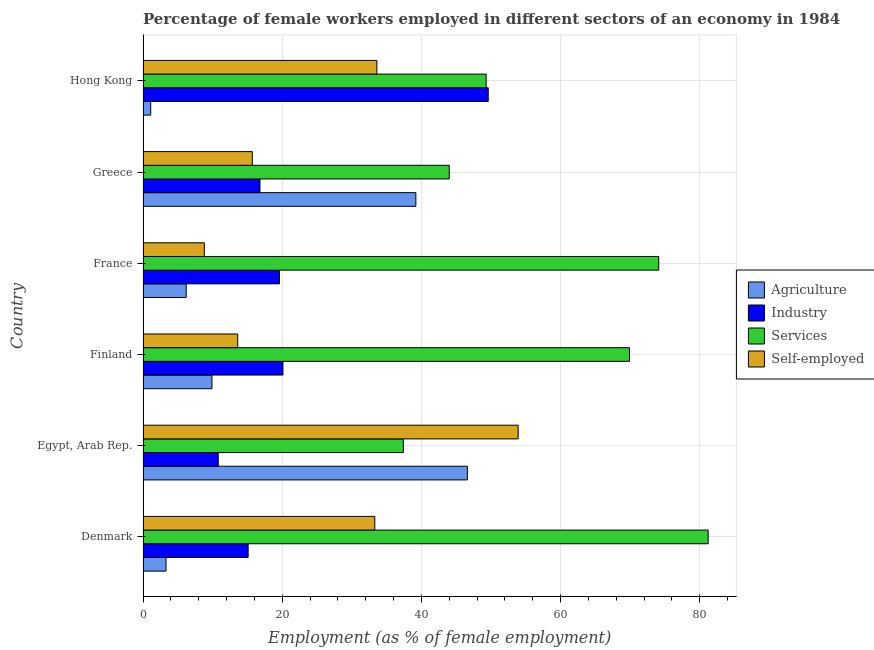In how many cases, is the number of bars for a given country not equal to the number of legend labels?
Keep it short and to the point. 0. What is the percentage of self employed female workers in France?
Provide a succinct answer. 8.8. Across all countries, what is the maximum percentage of female workers in agriculture?
Keep it short and to the point. 46.6. Across all countries, what is the minimum percentage of self employed female workers?
Your response must be concise. 8.8. In which country was the percentage of female workers in agriculture maximum?
Ensure brevity in your answer.  Egypt, Arab Rep. What is the total percentage of female workers in industry in the graph?
Ensure brevity in your answer.  132. What is the difference between the percentage of self employed female workers in Finland and the percentage of female workers in agriculture in Hong Kong?
Provide a short and direct response. 12.5. What is the average percentage of female workers in services per country?
Offer a very short reply. 59.32. What is the difference between the percentage of female workers in agriculture and percentage of female workers in services in Denmark?
Ensure brevity in your answer.  -77.9. In how many countries, is the percentage of female workers in industry greater than 72 %?
Offer a very short reply. 0. What is the ratio of the percentage of female workers in industry in France to that in Greece?
Provide a succinct answer. 1.17. Is the percentage of female workers in agriculture in Egypt, Arab Rep. less than that in Greece?
Provide a succinct answer. No. Is the difference between the percentage of self employed female workers in Finland and France greater than the difference between the percentage of female workers in agriculture in Finland and France?
Provide a succinct answer. Yes. What is the difference between the highest and the second highest percentage of self employed female workers?
Make the answer very short. 20.3. What is the difference between the highest and the lowest percentage of female workers in agriculture?
Provide a short and direct response. 45.5. In how many countries, is the percentage of female workers in industry greater than the average percentage of female workers in industry taken over all countries?
Your answer should be compact. 1. Is the sum of the percentage of female workers in services in Denmark and Hong Kong greater than the maximum percentage of female workers in industry across all countries?
Offer a very short reply. Yes. Is it the case that in every country, the sum of the percentage of self employed female workers and percentage of female workers in services is greater than the sum of percentage of female workers in industry and percentage of female workers in agriculture?
Your response must be concise. Yes. What does the 3rd bar from the top in Egypt, Arab Rep. represents?
Your answer should be compact. Industry. What does the 3rd bar from the bottom in Egypt, Arab Rep. represents?
Provide a succinct answer. Services. Is it the case that in every country, the sum of the percentage of female workers in agriculture and percentage of female workers in industry is greater than the percentage of female workers in services?
Offer a very short reply. No. Are all the bars in the graph horizontal?
Provide a succinct answer. Yes. Does the graph contain grids?
Your answer should be compact. Yes. How are the legend labels stacked?
Provide a succinct answer. Vertical. What is the title of the graph?
Make the answer very short. Percentage of female workers employed in different sectors of an economy in 1984. Does "Korea" appear as one of the legend labels in the graph?
Keep it short and to the point. No. What is the label or title of the X-axis?
Provide a short and direct response. Employment (as % of female employment). What is the Employment (as % of female employment) in Agriculture in Denmark?
Your response must be concise. 3.3. What is the Employment (as % of female employment) in Industry in Denmark?
Your answer should be very brief. 15.1. What is the Employment (as % of female employment) in Services in Denmark?
Your response must be concise. 81.2. What is the Employment (as % of female employment) of Self-employed in Denmark?
Give a very brief answer. 33.3. What is the Employment (as % of female employment) of Agriculture in Egypt, Arab Rep.?
Keep it short and to the point. 46.6. What is the Employment (as % of female employment) of Industry in Egypt, Arab Rep.?
Provide a succinct answer. 10.8. What is the Employment (as % of female employment) in Services in Egypt, Arab Rep.?
Make the answer very short. 37.4. What is the Employment (as % of female employment) of Self-employed in Egypt, Arab Rep.?
Make the answer very short. 53.9. What is the Employment (as % of female employment) in Agriculture in Finland?
Ensure brevity in your answer.  9.9. What is the Employment (as % of female employment) in Industry in Finland?
Your answer should be very brief. 20.1. What is the Employment (as % of female employment) in Services in Finland?
Your answer should be compact. 69.9. What is the Employment (as % of female employment) in Self-employed in Finland?
Ensure brevity in your answer.  13.6. What is the Employment (as % of female employment) of Agriculture in France?
Give a very brief answer. 6.2. What is the Employment (as % of female employment) of Industry in France?
Give a very brief answer. 19.6. What is the Employment (as % of female employment) of Services in France?
Your answer should be compact. 74.1. What is the Employment (as % of female employment) of Self-employed in France?
Ensure brevity in your answer.  8.8. What is the Employment (as % of female employment) in Agriculture in Greece?
Make the answer very short. 39.2. What is the Employment (as % of female employment) in Industry in Greece?
Give a very brief answer. 16.8. What is the Employment (as % of female employment) of Self-employed in Greece?
Keep it short and to the point. 15.7. What is the Employment (as % of female employment) of Agriculture in Hong Kong?
Keep it short and to the point. 1.1. What is the Employment (as % of female employment) in Industry in Hong Kong?
Give a very brief answer. 49.6. What is the Employment (as % of female employment) in Services in Hong Kong?
Your answer should be very brief. 49.3. What is the Employment (as % of female employment) in Self-employed in Hong Kong?
Offer a terse response. 33.6. Across all countries, what is the maximum Employment (as % of female employment) of Agriculture?
Give a very brief answer. 46.6. Across all countries, what is the maximum Employment (as % of female employment) in Industry?
Provide a short and direct response. 49.6. Across all countries, what is the maximum Employment (as % of female employment) of Services?
Your answer should be compact. 81.2. Across all countries, what is the maximum Employment (as % of female employment) in Self-employed?
Provide a succinct answer. 53.9. Across all countries, what is the minimum Employment (as % of female employment) in Agriculture?
Keep it short and to the point. 1.1. Across all countries, what is the minimum Employment (as % of female employment) of Industry?
Provide a short and direct response. 10.8. Across all countries, what is the minimum Employment (as % of female employment) in Services?
Offer a very short reply. 37.4. Across all countries, what is the minimum Employment (as % of female employment) in Self-employed?
Make the answer very short. 8.8. What is the total Employment (as % of female employment) of Agriculture in the graph?
Offer a terse response. 106.3. What is the total Employment (as % of female employment) in Industry in the graph?
Offer a very short reply. 132. What is the total Employment (as % of female employment) in Services in the graph?
Offer a terse response. 355.9. What is the total Employment (as % of female employment) of Self-employed in the graph?
Your response must be concise. 158.9. What is the difference between the Employment (as % of female employment) in Agriculture in Denmark and that in Egypt, Arab Rep.?
Make the answer very short. -43.3. What is the difference between the Employment (as % of female employment) of Services in Denmark and that in Egypt, Arab Rep.?
Offer a terse response. 43.8. What is the difference between the Employment (as % of female employment) in Self-employed in Denmark and that in Egypt, Arab Rep.?
Offer a very short reply. -20.6. What is the difference between the Employment (as % of female employment) of Agriculture in Denmark and that in Finland?
Your answer should be very brief. -6.6. What is the difference between the Employment (as % of female employment) in Services in Denmark and that in Finland?
Provide a short and direct response. 11.3. What is the difference between the Employment (as % of female employment) in Self-employed in Denmark and that in Finland?
Provide a succinct answer. 19.7. What is the difference between the Employment (as % of female employment) of Industry in Denmark and that in France?
Keep it short and to the point. -4.5. What is the difference between the Employment (as % of female employment) of Agriculture in Denmark and that in Greece?
Your answer should be compact. -35.9. What is the difference between the Employment (as % of female employment) of Industry in Denmark and that in Greece?
Keep it short and to the point. -1.7. What is the difference between the Employment (as % of female employment) in Services in Denmark and that in Greece?
Provide a short and direct response. 37.2. What is the difference between the Employment (as % of female employment) in Self-employed in Denmark and that in Greece?
Keep it short and to the point. 17.6. What is the difference between the Employment (as % of female employment) in Industry in Denmark and that in Hong Kong?
Your answer should be compact. -34.5. What is the difference between the Employment (as % of female employment) of Services in Denmark and that in Hong Kong?
Offer a very short reply. 31.9. What is the difference between the Employment (as % of female employment) in Self-employed in Denmark and that in Hong Kong?
Offer a terse response. -0.3. What is the difference between the Employment (as % of female employment) in Agriculture in Egypt, Arab Rep. and that in Finland?
Offer a very short reply. 36.7. What is the difference between the Employment (as % of female employment) of Industry in Egypt, Arab Rep. and that in Finland?
Your response must be concise. -9.3. What is the difference between the Employment (as % of female employment) in Services in Egypt, Arab Rep. and that in Finland?
Provide a succinct answer. -32.5. What is the difference between the Employment (as % of female employment) in Self-employed in Egypt, Arab Rep. and that in Finland?
Offer a very short reply. 40.3. What is the difference between the Employment (as % of female employment) of Agriculture in Egypt, Arab Rep. and that in France?
Offer a terse response. 40.4. What is the difference between the Employment (as % of female employment) in Industry in Egypt, Arab Rep. and that in France?
Ensure brevity in your answer.  -8.8. What is the difference between the Employment (as % of female employment) of Services in Egypt, Arab Rep. and that in France?
Keep it short and to the point. -36.7. What is the difference between the Employment (as % of female employment) of Self-employed in Egypt, Arab Rep. and that in France?
Make the answer very short. 45.1. What is the difference between the Employment (as % of female employment) in Agriculture in Egypt, Arab Rep. and that in Greece?
Offer a terse response. 7.4. What is the difference between the Employment (as % of female employment) in Self-employed in Egypt, Arab Rep. and that in Greece?
Provide a short and direct response. 38.2. What is the difference between the Employment (as % of female employment) of Agriculture in Egypt, Arab Rep. and that in Hong Kong?
Keep it short and to the point. 45.5. What is the difference between the Employment (as % of female employment) in Industry in Egypt, Arab Rep. and that in Hong Kong?
Provide a short and direct response. -38.8. What is the difference between the Employment (as % of female employment) of Self-employed in Egypt, Arab Rep. and that in Hong Kong?
Your response must be concise. 20.3. What is the difference between the Employment (as % of female employment) of Agriculture in Finland and that in France?
Provide a succinct answer. 3.7. What is the difference between the Employment (as % of female employment) of Agriculture in Finland and that in Greece?
Ensure brevity in your answer.  -29.3. What is the difference between the Employment (as % of female employment) in Services in Finland and that in Greece?
Your answer should be compact. 25.9. What is the difference between the Employment (as % of female employment) in Self-employed in Finland and that in Greece?
Ensure brevity in your answer.  -2.1. What is the difference between the Employment (as % of female employment) of Industry in Finland and that in Hong Kong?
Provide a short and direct response. -29.5. What is the difference between the Employment (as % of female employment) of Services in Finland and that in Hong Kong?
Make the answer very short. 20.6. What is the difference between the Employment (as % of female employment) in Self-employed in Finland and that in Hong Kong?
Your response must be concise. -20. What is the difference between the Employment (as % of female employment) in Agriculture in France and that in Greece?
Offer a very short reply. -33. What is the difference between the Employment (as % of female employment) in Industry in France and that in Greece?
Keep it short and to the point. 2.8. What is the difference between the Employment (as % of female employment) in Services in France and that in Greece?
Keep it short and to the point. 30.1. What is the difference between the Employment (as % of female employment) in Industry in France and that in Hong Kong?
Offer a terse response. -30. What is the difference between the Employment (as % of female employment) of Services in France and that in Hong Kong?
Provide a short and direct response. 24.8. What is the difference between the Employment (as % of female employment) of Self-employed in France and that in Hong Kong?
Your answer should be compact. -24.8. What is the difference between the Employment (as % of female employment) of Agriculture in Greece and that in Hong Kong?
Provide a short and direct response. 38.1. What is the difference between the Employment (as % of female employment) in Industry in Greece and that in Hong Kong?
Your answer should be very brief. -32.8. What is the difference between the Employment (as % of female employment) of Self-employed in Greece and that in Hong Kong?
Offer a terse response. -17.9. What is the difference between the Employment (as % of female employment) of Agriculture in Denmark and the Employment (as % of female employment) of Services in Egypt, Arab Rep.?
Offer a terse response. -34.1. What is the difference between the Employment (as % of female employment) in Agriculture in Denmark and the Employment (as % of female employment) in Self-employed in Egypt, Arab Rep.?
Offer a terse response. -50.6. What is the difference between the Employment (as % of female employment) in Industry in Denmark and the Employment (as % of female employment) in Services in Egypt, Arab Rep.?
Ensure brevity in your answer.  -22.3. What is the difference between the Employment (as % of female employment) of Industry in Denmark and the Employment (as % of female employment) of Self-employed in Egypt, Arab Rep.?
Your answer should be very brief. -38.8. What is the difference between the Employment (as % of female employment) of Services in Denmark and the Employment (as % of female employment) of Self-employed in Egypt, Arab Rep.?
Your answer should be compact. 27.3. What is the difference between the Employment (as % of female employment) in Agriculture in Denmark and the Employment (as % of female employment) in Industry in Finland?
Provide a succinct answer. -16.8. What is the difference between the Employment (as % of female employment) in Agriculture in Denmark and the Employment (as % of female employment) in Services in Finland?
Give a very brief answer. -66.6. What is the difference between the Employment (as % of female employment) in Industry in Denmark and the Employment (as % of female employment) in Services in Finland?
Your answer should be very brief. -54.8. What is the difference between the Employment (as % of female employment) of Industry in Denmark and the Employment (as % of female employment) of Self-employed in Finland?
Provide a succinct answer. 1.5. What is the difference between the Employment (as % of female employment) in Services in Denmark and the Employment (as % of female employment) in Self-employed in Finland?
Your response must be concise. 67.6. What is the difference between the Employment (as % of female employment) of Agriculture in Denmark and the Employment (as % of female employment) of Industry in France?
Provide a succinct answer. -16.3. What is the difference between the Employment (as % of female employment) in Agriculture in Denmark and the Employment (as % of female employment) in Services in France?
Keep it short and to the point. -70.8. What is the difference between the Employment (as % of female employment) of Agriculture in Denmark and the Employment (as % of female employment) of Self-employed in France?
Provide a succinct answer. -5.5. What is the difference between the Employment (as % of female employment) of Industry in Denmark and the Employment (as % of female employment) of Services in France?
Give a very brief answer. -59. What is the difference between the Employment (as % of female employment) in Services in Denmark and the Employment (as % of female employment) in Self-employed in France?
Give a very brief answer. 72.4. What is the difference between the Employment (as % of female employment) of Agriculture in Denmark and the Employment (as % of female employment) of Services in Greece?
Your answer should be very brief. -40.7. What is the difference between the Employment (as % of female employment) in Agriculture in Denmark and the Employment (as % of female employment) in Self-employed in Greece?
Your response must be concise. -12.4. What is the difference between the Employment (as % of female employment) of Industry in Denmark and the Employment (as % of female employment) of Services in Greece?
Keep it short and to the point. -28.9. What is the difference between the Employment (as % of female employment) of Services in Denmark and the Employment (as % of female employment) of Self-employed in Greece?
Your answer should be very brief. 65.5. What is the difference between the Employment (as % of female employment) of Agriculture in Denmark and the Employment (as % of female employment) of Industry in Hong Kong?
Your answer should be very brief. -46.3. What is the difference between the Employment (as % of female employment) of Agriculture in Denmark and the Employment (as % of female employment) of Services in Hong Kong?
Offer a terse response. -46. What is the difference between the Employment (as % of female employment) in Agriculture in Denmark and the Employment (as % of female employment) in Self-employed in Hong Kong?
Your response must be concise. -30.3. What is the difference between the Employment (as % of female employment) of Industry in Denmark and the Employment (as % of female employment) of Services in Hong Kong?
Ensure brevity in your answer.  -34.2. What is the difference between the Employment (as % of female employment) in Industry in Denmark and the Employment (as % of female employment) in Self-employed in Hong Kong?
Provide a succinct answer. -18.5. What is the difference between the Employment (as % of female employment) in Services in Denmark and the Employment (as % of female employment) in Self-employed in Hong Kong?
Give a very brief answer. 47.6. What is the difference between the Employment (as % of female employment) in Agriculture in Egypt, Arab Rep. and the Employment (as % of female employment) in Industry in Finland?
Give a very brief answer. 26.5. What is the difference between the Employment (as % of female employment) of Agriculture in Egypt, Arab Rep. and the Employment (as % of female employment) of Services in Finland?
Make the answer very short. -23.3. What is the difference between the Employment (as % of female employment) in Industry in Egypt, Arab Rep. and the Employment (as % of female employment) in Services in Finland?
Keep it short and to the point. -59.1. What is the difference between the Employment (as % of female employment) in Services in Egypt, Arab Rep. and the Employment (as % of female employment) in Self-employed in Finland?
Ensure brevity in your answer.  23.8. What is the difference between the Employment (as % of female employment) of Agriculture in Egypt, Arab Rep. and the Employment (as % of female employment) of Industry in France?
Offer a terse response. 27. What is the difference between the Employment (as % of female employment) in Agriculture in Egypt, Arab Rep. and the Employment (as % of female employment) in Services in France?
Your answer should be very brief. -27.5. What is the difference between the Employment (as % of female employment) in Agriculture in Egypt, Arab Rep. and the Employment (as % of female employment) in Self-employed in France?
Ensure brevity in your answer.  37.8. What is the difference between the Employment (as % of female employment) in Industry in Egypt, Arab Rep. and the Employment (as % of female employment) in Services in France?
Your answer should be compact. -63.3. What is the difference between the Employment (as % of female employment) in Services in Egypt, Arab Rep. and the Employment (as % of female employment) in Self-employed in France?
Your response must be concise. 28.6. What is the difference between the Employment (as % of female employment) of Agriculture in Egypt, Arab Rep. and the Employment (as % of female employment) of Industry in Greece?
Ensure brevity in your answer.  29.8. What is the difference between the Employment (as % of female employment) in Agriculture in Egypt, Arab Rep. and the Employment (as % of female employment) in Self-employed in Greece?
Your answer should be compact. 30.9. What is the difference between the Employment (as % of female employment) in Industry in Egypt, Arab Rep. and the Employment (as % of female employment) in Services in Greece?
Provide a succinct answer. -33.2. What is the difference between the Employment (as % of female employment) in Industry in Egypt, Arab Rep. and the Employment (as % of female employment) in Self-employed in Greece?
Keep it short and to the point. -4.9. What is the difference between the Employment (as % of female employment) in Services in Egypt, Arab Rep. and the Employment (as % of female employment) in Self-employed in Greece?
Offer a very short reply. 21.7. What is the difference between the Employment (as % of female employment) of Agriculture in Egypt, Arab Rep. and the Employment (as % of female employment) of Industry in Hong Kong?
Offer a terse response. -3. What is the difference between the Employment (as % of female employment) of Agriculture in Egypt, Arab Rep. and the Employment (as % of female employment) of Self-employed in Hong Kong?
Provide a succinct answer. 13. What is the difference between the Employment (as % of female employment) in Industry in Egypt, Arab Rep. and the Employment (as % of female employment) in Services in Hong Kong?
Provide a short and direct response. -38.5. What is the difference between the Employment (as % of female employment) in Industry in Egypt, Arab Rep. and the Employment (as % of female employment) in Self-employed in Hong Kong?
Ensure brevity in your answer.  -22.8. What is the difference between the Employment (as % of female employment) of Agriculture in Finland and the Employment (as % of female employment) of Industry in France?
Provide a short and direct response. -9.7. What is the difference between the Employment (as % of female employment) of Agriculture in Finland and the Employment (as % of female employment) of Services in France?
Give a very brief answer. -64.2. What is the difference between the Employment (as % of female employment) of Industry in Finland and the Employment (as % of female employment) of Services in France?
Make the answer very short. -54. What is the difference between the Employment (as % of female employment) in Services in Finland and the Employment (as % of female employment) in Self-employed in France?
Keep it short and to the point. 61.1. What is the difference between the Employment (as % of female employment) in Agriculture in Finland and the Employment (as % of female employment) in Services in Greece?
Provide a short and direct response. -34.1. What is the difference between the Employment (as % of female employment) in Industry in Finland and the Employment (as % of female employment) in Services in Greece?
Your answer should be compact. -23.9. What is the difference between the Employment (as % of female employment) in Services in Finland and the Employment (as % of female employment) in Self-employed in Greece?
Offer a very short reply. 54.2. What is the difference between the Employment (as % of female employment) in Agriculture in Finland and the Employment (as % of female employment) in Industry in Hong Kong?
Your answer should be compact. -39.7. What is the difference between the Employment (as % of female employment) in Agriculture in Finland and the Employment (as % of female employment) in Services in Hong Kong?
Offer a very short reply. -39.4. What is the difference between the Employment (as % of female employment) of Agriculture in Finland and the Employment (as % of female employment) of Self-employed in Hong Kong?
Ensure brevity in your answer.  -23.7. What is the difference between the Employment (as % of female employment) in Industry in Finland and the Employment (as % of female employment) in Services in Hong Kong?
Your answer should be compact. -29.2. What is the difference between the Employment (as % of female employment) in Services in Finland and the Employment (as % of female employment) in Self-employed in Hong Kong?
Ensure brevity in your answer.  36.3. What is the difference between the Employment (as % of female employment) of Agriculture in France and the Employment (as % of female employment) of Industry in Greece?
Make the answer very short. -10.6. What is the difference between the Employment (as % of female employment) in Agriculture in France and the Employment (as % of female employment) in Services in Greece?
Offer a very short reply. -37.8. What is the difference between the Employment (as % of female employment) of Industry in France and the Employment (as % of female employment) of Services in Greece?
Keep it short and to the point. -24.4. What is the difference between the Employment (as % of female employment) in Services in France and the Employment (as % of female employment) in Self-employed in Greece?
Ensure brevity in your answer.  58.4. What is the difference between the Employment (as % of female employment) of Agriculture in France and the Employment (as % of female employment) of Industry in Hong Kong?
Ensure brevity in your answer.  -43.4. What is the difference between the Employment (as % of female employment) in Agriculture in France and the Employment (as % of female employment) in Services in Hong Kong?
Keep it short and to the point. -43.1. What is the difference between the Employment (as % of female employment) in Agriculture in France and the Employment (as % of female employment) in Self-employed in Hong Kong?
Make the answer very short. -27.4. What is the difference between the Employment (as % of female employment) of Industry in France and the Employment (as % of female employment) of Services in Hong Kong?
Offer a terse response. -29.7. What is the difference between the Employment (as % of female employment) in Services in France and the Employment (as % of female employment) in Self-employed in Hong Kong?
Ensure brevity in your answer.  40.5. What is the difference between the Employment (as % of female employment) in Agriculture in Greece and the Employment (as % of female employment) in Self-employed in Hong Kong?
Make the answer very short. 5.6. What is the difference between the Employment (as % of female employment) in Industry in Greece and the Employment (as % of female employment) in Services in Hong Kong?
Provide a succinct answer. -32.5. What is the difference between the Employment (as % of female employment) in Industry in Greece and the Employment (as % of female employment) in Self-employed in Hong Kong?
Keep it short and to the point. -16.8. What is the average Employment (as % of female employment) in Agriculture per country?
Your answer should be compact. 17.72. What is the average Employment (as % of female employment) of Services per country?
Your response must be concise. 59.32. What is the average Employment (as % of female employment) of Self-employed per country?
Keep it short and to the point. 26.48. What is the difference between the Employment (as % of female employment) of Agriculture and Employment (as % of female employment) of Industry in Denmark?
Your answer should be very brief. -11.8. What is the difference between the Employment (as % of female employment) of Agriculture and Employment (as % of female employment) of Services in Denmark?
Offer a terse response. -77.9. What is the difference between the Employment (as % of female employment) in Agriculture and Employment (as % of female employment) in Self-employed in Denmark?
Offer a very short reply. -30. What is the difference between the Employment (as % of female employment) of Industry and Employment (as % of female employment) of Services in Denmark?
Your answer should be very brief. -66.1. What is the difference between the Employment (as % of female employment) in Industry and Employment (as % of female employment) in Self-employed in Denmark?
Your answer should be compact. -18.2. What is the difference between the Employment (as % of female employment) of Services and Employment (as % of female employment) of Self-employed in Denmark?
Ensure brevity in your answer.  47.9. What is the difference between the Employment (as % of female employment) of Agriculture and Employment (as % of female employment) of Industry in Egypt, Arab Rep.?
Keep it short and to the point. 35.8. What is the difference between the Employment (as % of female employment) in Industry and Employment (as % of female employment) in Services in Egypt, Arab Rep.?
Provide a succinct answer. -26.6. What is the difference between the Employment (as % of female employment) in Industry and Employment (as % of female employment) in Self-employed in Egypt, Arab Rep.?
Make the answer very short. -43.1. What is the difference between the Employment (as % of female employment) of Services and Employment (as % of female employment) of Self-employed in Egypt, Arab Rep.?
Provide a short and direct response. -16.5. What is the difference between the Employment (as % of female employment) in Agriculture and Employment (as % of female employment) in Services in Finland?
Your answer should be compact. -60. What is the difference between the Employment (as % of female employment) of Industry and Employment (as % of female employment) of Services in Finland?
Your answer should be very brief. -49.8. What is the difference between the Employment (as % of female employment) in Industry and Employment (as % of female employment) in Self-employed in Finland?
Make the answer very short. 6.5. What is the difference between the Employment (as % of female employment) in Services and Employment (as % of female employment) in Self-employed in Finland?
Your answer should be very brief. 56.3. What is the difference between the Employment (as % of female employment) in Agriculture and Employment (as % of female employment) in Industry in France?
Make the answer very short. -13.4. What is the difference between the Employment (as % of female employment) of Agriculture and Employment (as % of female employment) of Services in France?
Provide a short and direct response. -67.9. What is the difference between the Employment (as % of female employment) in Industry and Employment (as % of female employment) in Services in France?
Your answer should be very brief. -54.5. What is the difference between the Employment (as % of female employment) in Industry and Employment (as % of female employment) in Self-employed in France?
Make the answer very short. 10.8. What is the difference between the Employment (as % of female employment) of Services and Employment (as % of female employment) of Self-employed in France?
Provide a succinct answer. 65.3. What is the difference between the Employment (as % of female employment) of Agriculture and Employment (as % of female employment) of Industry in Greece?
Offer a very short reply. 22.4. What is the difference between the Employment (as % of female employment) of Agriculture and Employment (as % of female employment) of Services in Greece?
Ensure brevity in your answer.  -4.8. What is the difference between the Employment (as % of female employment) of Agriculture and Employment (as % of female employment) of Self-employed in Greece?
Ensure brevity in your answer.  23.5. What is the difference between the Employment (as % of female employment) in Industry and Employment (as % of female employment) in Services in Greece?
Ensure brevity in your answer.  -27.2. What is the difference between the Employment (as % of female employment) of Services and Employment (as % of female employment) of Self-employed in Greece?
Keep it short and to the point. 28.3. What is the difference between the Employment (as % of female employment) in Agriculture and Employment (as % of female employment) in Industry in Hong Kong?
Your answer should be very brief. -48.5. What is the difference between the Employment (as % of female employment) in Agriculture and Employment (as % of female employment) in Services in Hong Kong?
Your response must be concise. -48.2. What is the difference between the Employment (as % of female employment) of Agriculture and Employment (as % of female employment) of Self-employed in Hong Kong?
Keep it short and to the point. -32.5. What is the difference between the Employment (as % of female employment) of Industry and Employment (as % of female employment) of Services in Hong Kong?
Give a very brief answer. 0.3. What is the difference between the Employment (as % of female employment) of Services and Employment (as % of female employment) of Self-employed in Hong Kong?
Provide a succinct answer. 15.7. What is the ratio of the Employment (as % of female employment) of Agriculture in Denmark to that in Egypt, Arab Rep.?
Your answer should be very brief. 0.07. What is the ratio of the Employment (as % of female employment) in Industry in Denmark to that in Egypt, Arab Rep.?
Provide a succinct answer. 1.4. What is the ratio of the Employment (as % of female employment) in Services in Denmark to that in Egypt, Arab Rep.?
Your response must be concise. 2.17. What is the ratio of the Employment (as % of female employment) of Self-employed in Denmark to that in Egypt, Arab Rep.?
Give a very brief answer. 0.62. What is the ratio of the Employment (as % of female employment) in Industry in Denmark to that in Finland?
Offer a terse response. 0.75. What is the ratio of the Employment (as % of female employment) in Services in Denmark to that in Finland?
Provide a succinct answer. 1.16. What is the ratio of the Employment (as % of female employment) in Self-employed in Denmark to that in Finland?
Your answer should be very brief. 2.45. What is the ratio of the Employment (as % of female employment) of Agriculture in Denmark to that in France?
Ensure brevity in your answer.  0.53. What is the ratio of the Employment (as % of female employment) of Industry in Denmark to that in France?
Offer a very short reply. 0.77. What is the ratio of the Employment (as % of female employment) in Services in Denmark to that in France?
Your answer should be very brief. 1.1. What is the ratio of the Employment (as % of female employment) in Self-employed in Denmark to that in France?
Provide a succinct answer. 3.78. What is the ratio of the Employment (as % of female employment) in Agriculture in Denmark to that in Greece?
Offer a very short reply. 0.08. What is the ratio of the Employment (as % of female employment) in Industry in Denmark to that in Greece?
Your answer should be very brief. 0.9. What is the ratio of the Employment (as % of female employment) in Services in Denmark to that in Greece?
Ensure brevity in your answer.  1.85. What is the ratio of the Employment (as % of female employment) of Self-employed in Denmark to that in Greece?
Your response must be concise. 2.12. What is the ratio of the Employment (as % of female employment) in Agriculture in Denmark to that in Hong Kong?
Keep it short and to the point. 3. What is the ratio of the Employment (as % of female employment) in Industry in Denmark to that in Hong Kong?
Your response must be concise. 0.3. What is the ratio of the Employment (as % of female employment) in Services in Denmark to that in Hong Kong?
Your response must be concise. 1.65. What is the ratio of the Employment (as % of female employment) in Agriculture in Egypt, Arab Rep. to that in Finland?
Offer a terse response. 4.71. What is the ratio of the Employment (as % of female employment) of Industry in Egypt, Arab Rep. to that in Finland?
Provide a succinct answer. 0.54. What is the ratio of the Employment (as % of female employment) of Services in Egypt, Arab Rep. to that in Finland?
Offer a very short reply. 0.54. What is the ratio of the Employment (as % of female employment) of Self-employed in Egypt, Arab Rep. to that in Finland?
Ensure brevity in your answer.  3.96. What is the ratio of the Employment (as % of female employment) of Agriculture in Egypt, Arab Rep. to that in France?
Your response must be concise. 7.52. What is the ratio of the Employment (as % of female employment) in Industry in Egypt, Arab Rep. to that in France?
Offer a very short reply. 0.55. What is the ratio of the Employment (as % of female employment) in Services in Egypt, Arab Rep. to that in France?
Offer a terse response. 0.5. What is the ratio of the Employment (as % of female employment) of Self-employed in Egypt, Arab Rep. to that in France?
Your response must be concise. 6.12. What is the ratio of the Employment (as % of female employment) of Agriculture in Egypt, Arab Rep. to that in Greece?
Your response must be concise. 1.19. What is the ratio of the Employment (as % of female employment) in Industry in Egypt, Arab Rep. to that in Greece?
Provide a short and direct response. 0.64. What is the ratio of the Employment (as % of female employment) of Self-employed in Egypt, Arab Rep. to that in Greece?
Your answer should be compact. 3.43. What is the ratio of the Employment (as % of female employment) in Agriculture in Egypt, Arab Rep. to that in Hong Kong?
Keep it short and to the point. 42.36. What is the ratio of the Employment (as % of female employment) in Industry in Egypt, Arab Rep. to that in Hong Kong?
Offer a very short reply. 0.22. What is the ratio of the Employment (as % of female employment) of Services in Egypt, Arab Rep. to that in Hong Kong?
Provide a short and direct response. 0.76. What is the ratio of the Employment (as % of female employment) in Self-employed in Egypt, Arab Rep. to that in Hong Kong?
Make the answer very short. 1.6. What is the ratio of the Employment (as % of female employment) in Agriculture in Finland to that in France?
Your answer should be compact. 1.6. What is the ratio of the Employment (as % of female employment) in Industry in Finland to that in France?
Give a very brief answer. 1.03. What is the ratio of the Employment (as % of female employment) of Services in Finland to that in France?
Provide a short and direct response. 0.94. What is the ratio of the Employment (as % of female employment) in Self-employed in Finland to that in France?
Make the answer very short. 1.55. What is the ratio of the Employment (as % of female employment) of Agriculture in Finland to that in Greece?
Provide a short and direct response. 0.25. What is the ratio of the Employment (as % of female employment) of Industry in Finland to that in Greece?
Keep it short and to the point. 1.2. What is the ratio of the Employment (as % of female employment) in Services in Finland to that in Greece?
Offer a terse response. 1.59. What is the ratio of the Employment (as % of female employment) in Self-employed in Finland to that in Greece?
Offer a terse response. 0.87. What is the ratio of the Employment (as % of female employment) of Agriculture in Finland to that in Hong Kong?
Ensure brevity in your answer.  9. What is the ratio of the Employment (as % of female employment) in Industry in Finland to that in Hong Kong?
Give a very brief answer. 0.41. What is the ratio of the Employment (as % of female employment) of Services in Finland to that in Hong Kong?
Your response must be concise. 1.42. What is the ratio of the Employment (as % of female employment) of Self-employed in Finland to that in Hong Kong?
Provide a succinct answer. 0.4. What is the ratio of the Employment (as % of female employment) in Agriculture in France to that in Greece?
Keep it short and to the point. 0.16. What is the ratio of the Employment (as % of female employment) of Services in France to that in Greece?
Your answer should be compact. 1.68. What is the ratio of the Employment (as % of female employment) of Self-employed in France to that in Greece?
Make the answer very short. 0.56. What is the ratio of the Employment (as % of female employment) of Agriculture in France to that in Hong Kong?
Keep it short and to the point. 5.64. What is the ratio of the Employment (as % of female employment) in Industry in France to that in Hong Kong?
Provide a short and direct response. 0.4. What is the ratio of the Employment (as % of female employment) of Services in France to that in Hong Kong?
Ensure brevity in your answer.  1.5. What is the ratio of the Employment (as % of female employment) of Self-employed in France to that in Hong Kong?
Your answer should be very brief. 0.26. What is the ratio of the Employment (as % of female employment) in Agriculture in Greece to that in Hong Kong?
Offer a terse response. 35.64. What is the ratio of the Employment (as % of female employment) of Industry in Greece to that in Hong Kong?
Provide a short and direct response. 0.34. What is the ratio of the Employment (as % of female employment) in Services in Greece to that in Hong Kong?
Ensure brevity in your answer.  0.89. What is the ratio of the Employment (as % of female employment) in Self-employed in Greece to that in Hong Kong?
Provide a short and direct response. 0.47. What is the difference between the highest and the second highest Employment (as % of female employment) in Industry?
Provide a succinct answer. 29.5. What is the difference between the highest and the second highest Employment (as % of female employment) of Services?
Your answer should be compact. 7.1. What is the difference between the highest and the second highest Employment (as % of female employment) of Self-employed?
Offer a very short reply. 20.3. What is the difference between the highest and the lowest Employment (as % of female employment) in Agriculture?
Offer a very short reply. 45.5. What is the difference between the highest and the lowest Employment (as % of female employment) in Industry?
Ensure brevity in your answer.  38.8. What is the difference between the highest and the lowest Employment (as % of female employment) in Services?
Your answer should be compact. 43.8. What is the difference between the highest and the lowest Employment (as % of female employment) of Self-employed?
Your answer should be compact. 45.1. 